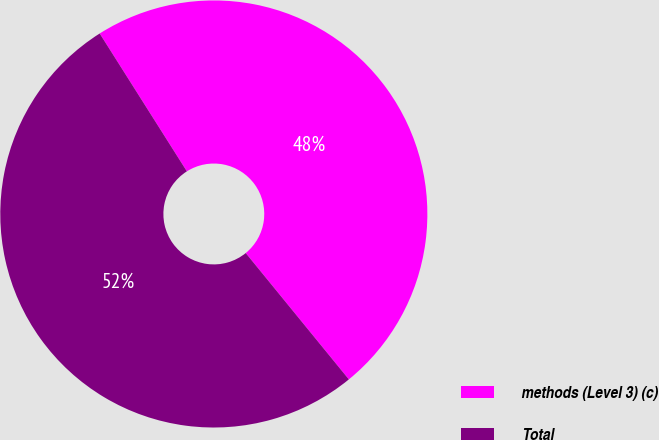Convert chart. <chart><loc_0><loc_0><loc_500><loc_500><pie_chart><fcel>methods (Level 3) (c)<fcel>Total<nl><fcel>48.08%<fcel>51.92%<nl></chart> 